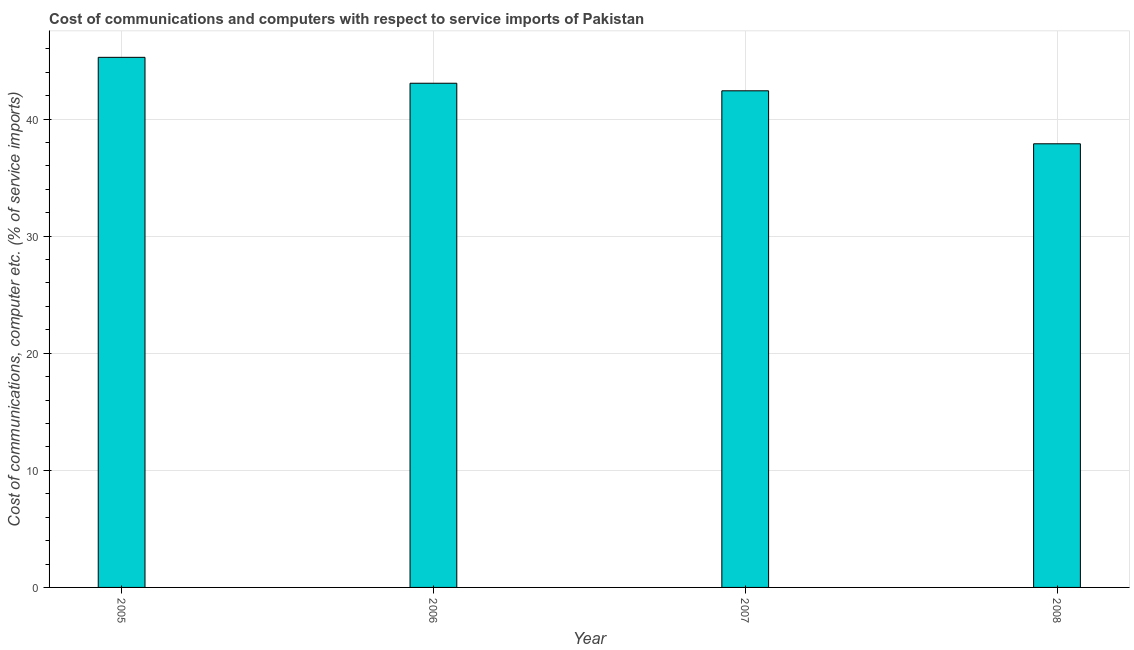Does the graph contain any zero values?
Your answer should be very brief. No. Does the graph contain grids?
Your answer should be compact. Yes. What is the title of the graph?
Offer a terse response. Cost of communications and computers with respect to service imports of Pakistan. What is the label or title of the Y-axis?
Give a very brief answer. Cost of communications, computer etc. (% of service imports). What is the cost of communications and computer in 2006?
Keep it short and to the point. 43.06. Across all years, what is the maximum cost of communications and computer?
Your response must be concise. 45.27. Across all years, what is the minimum cost of communications and computer?
Make the answer very short. 37.89. In which year was the cost of communications and computer maximum?
Your response must be concise. 2005. In which year was the cost of communications and computer minimum?
Offer a very short reply. 2008. What is the sum of the cost of communications and computer?
Provide a short and direct response. 168.62. What is the difference between the cost of communications and computer in 2006 and 2007?
Keep it short and to the point. 0.65. What is the average cost of communications and computer per year?
Your answer should be compact. 42.16. What is the median cost of communications and computer?
Make the answer very short. 42.73. Do a majority of the years between 2006 and 2007 (inclusive) have cost of communications and computer greater than 32 %?
Provide a succinct answer. Yes. What is the ratio of the cost of communications and computer in 2005 to that in 2006?
Provide a succinct answer. 1.05. Is the difference between the cost of communications and computer in 2005 and 2006 greater than the difference between any two years?
Provide a short and direct response. No. What is the difference between the highest and the second highest cost of communications and computer?
Your answer should be very brief. 2.21. What is the difference between the highest and the lowest cost of communications and computer?
Your response must be concise. 7.38. In how many years, is the cost of communications and computer greater than the average cost of communications and computer taken over all years?
Make the answer very short. 3. How many bars are there?
Offer a very short reply. 4. Are all the bars in the graph horizontal?
Provide a succinct answer. No. What is the difference between two consecutive major ticks on the Y-axis?
Offer a very short reply. 10. What is the Cost of communications, computer etc. (% of service imports) of 2005?
Provide a short and direct response. 45.27. What is the Cost of communications, computer etc. (% of service imports) of 2006?
Give a very brief answer. 43.06. What is the Cost of communications, computer etc. (% of service imports) of 2007?
Ensure brevity in your answer.  42.41. What is the Cost of communications, computer etc. (% of service imports) in 2008?
Your answer should be very brief. 37.89. What is the difference between the Cost of communications, computer etc. (% of service imports) in 2005 and 2006?
Your answer should be very brief. 2.21. What is the difference between the Cost of communications, computer etc. (% of service imports) in 2005 and 2007?
Your answer should be very brief. 2.86. What is the difference between the Cost of communications, computer etc. (% of service imports) in 2005 and 2008?
Keep it short and to the point. 7.38. What is the difference between the Cost of communications, computer etc. (% of service imports) in 2006 and 2007?
Keep it short and to the point. 0.65. What is the difference between the Cost of communications, computer etc. (% of service imports) in 2006 and 2008?
Offer a very short reply. 5.17. What is the difference between the Cost of communications, computer etc. (% of service imports) in 2007 and 2008?
Provide a short and direct response. 4.52. What is the ratio of the Cost of communications, computer etc. (% of service imports) in 2005 to that in 2006?
Offer a very short reply. 1.05. What is the ratio of the Cost of communications, computer etc. (% of service imports) in 2005 to that in 2007?
Offer a terse response. 1.07. What is the ratio of the Cost of communications, computer etc. (% of service imports) in 2005 to that in 2008?
Keep it short and to the point. 1.2. What is the ratio of the Cost of communications, computer etc. (% of service imports) in 2006 to that in 2007?
Make the answer very short. 1.01. What is the ratio of the Cost of communications, computer etc. (% of service imports) in 2006 to that in 2008?
Your answer should be very brief. 1.14. What is the ratio of the Cost of communications, computer etc. (% of service imports) in 2007 to that in 2008?
Offer a terse response. 1.12. 